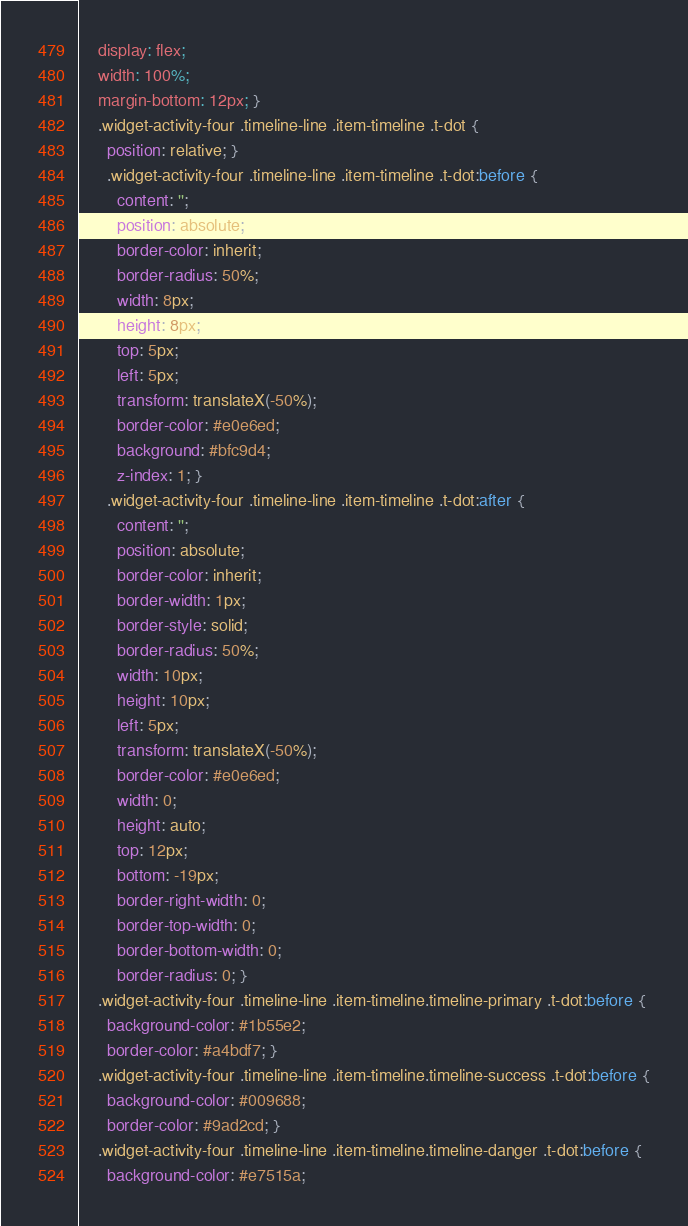Convert code to text. <code><loc_0><loc_0><loc_500><loc_500><_CSS_>    display: flex;
    width: 100%;
    margin-bottom: 12px; }
    .widget-activity-four .timeline-line .item-timeline .t-dot {
      position: relative; }
      .widget-activity-four .timeline-line .item-timeline .t-dot:before {
        content: '';
        position: absolute;
        border-color: inherit;
        border-radius: 50%;
        width: 8px;
        height: 8px;
        top: 5px;
        left: 5px;
        transform: translateX(-50%);
        border-color: #e0e6ed;
        background: #bfc9d4;
        z-index: 1; }
      .widget-activity-four .timeline-line .item-timeline .t-dot:after {
        content: '';
        position: absolute;
        border-color: inherit;
        border-width: 1px;
        border-style: solid;
        border-radius: 50%;
        width: 10px;
        height: 10px;
        left: 5px;
        transform: translateX(-50%);
        border-color: #e0e6ed;
        width: 0;
        height: auto;
        top: 12px;
        bottom: -19px;
        border-right-width: 0;
        border-top-width: 0;
        border-bottom-width: 0;
        border-radius: 0; }
    .widget-activity-four .timeline-line .item-timeline.timeline-primary .t-dot:before {
      background-color: #1b55e2;
      border-color: #a4bdf7; }
    .widget-activity-four .timeline-line .item-timeline.timeline-success .t-dot:before {
      background-color: #009688;
      border-color: #9ad2cd; }
    .widget-activity-four .timeline-line .item-timeline.timeline-danger .t-dot:before {
      background-color: #e7515a;</code> 